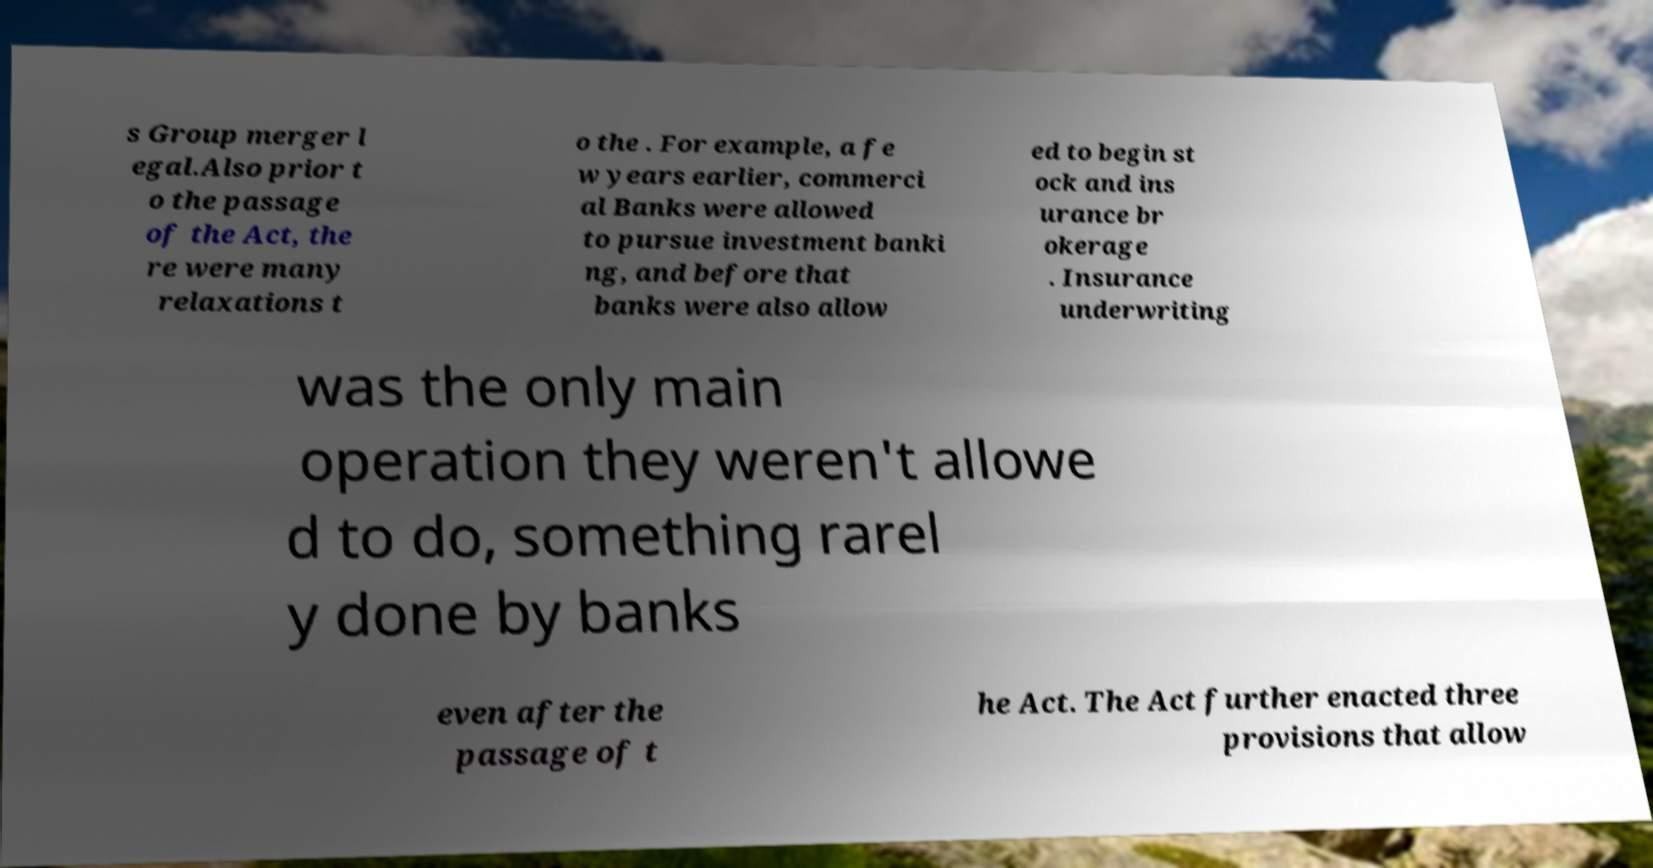What messages or text are displayed in this image? I need them in a readable, typed format. s Group merger l egal.Also prior t o the passage of the Act, the re were many relaxations t o the . For example, a fe w years earlier, commerci al Banks were allowed to pursue investment banki ng, and before that banks were also allow ed to begin st ock and ins urance br okerage . Insurance underwriting was the only main operation they weren't allowe d to do, something rarel y done by banks even after the passage of t he Act. The Act further enacted three provisions that allow 